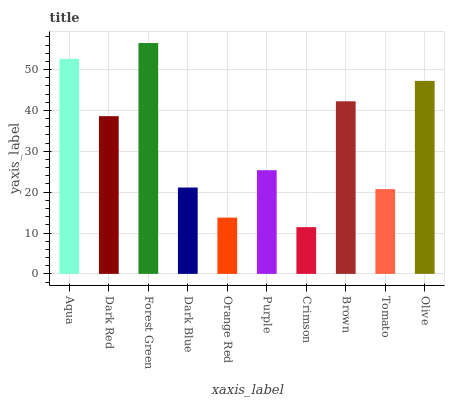Is Dark Red the minimum?
Answer yes or no. No. Is Dark Red the maximum?
Answer yes or no. No. Is Aqua greater than Dark Red?
Answer yes or no. Yes. Is Dark Red less than Aqua?
Answer yes or no. Yes. Is Dark Red greater than Aqua?
Answer yes or no. No. Is Aqua less than Dark Red?
Answer yes or no. No. Is Dark Red the high median?
Answer yes or no. Yes. Is Purple the low median?
Answer yes or no. Yes. Is Brown the high median?
Answer yes or no. No. Is Forest Green the low median?
Answer yes or no. No. 